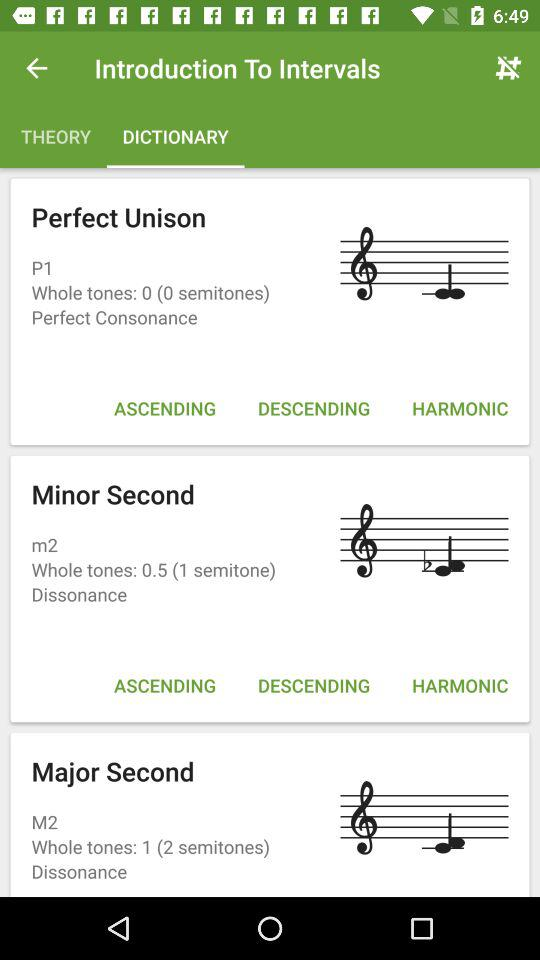How many dissonances are there?
Answer the question using a single word or phrase. 2 